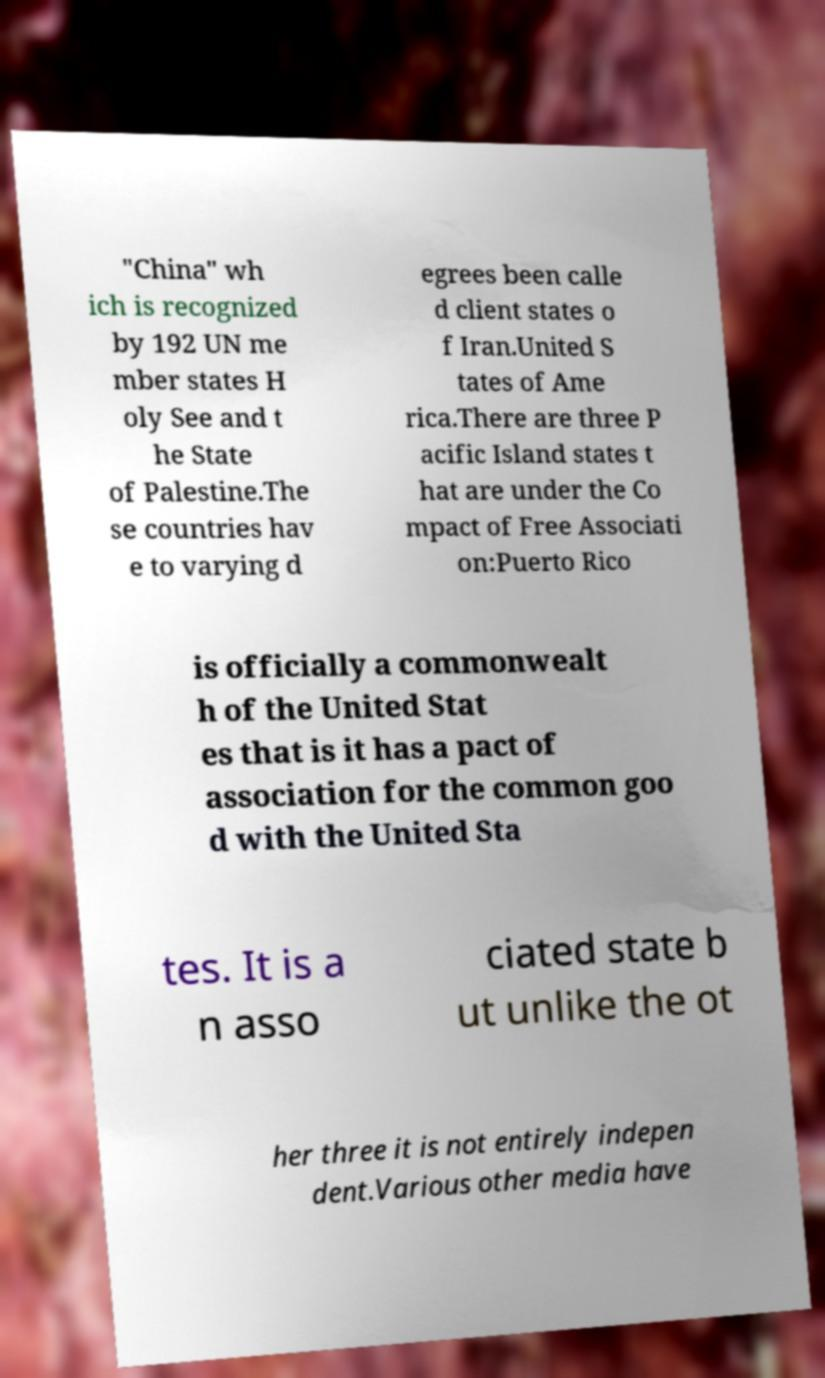Could you extract and type out the text from this image? "China" wh ich is recognized by 192 UN me mber states H oly See and t he State of Palestine.The se countries hav e to varying d egrees been calle d client states o f Iran.United S tates of Ame rica.There are three P acific Island states t hat are under the Co mpact of Free Associati on:Puerto Rico is officially a commonwealt h of the United Stat es that is it has a pact of association for the common goo d with the United Sta tes. It is a n asso ciated state b ut unlike the ot her three it is not entirely indepen dent.Various other media have 